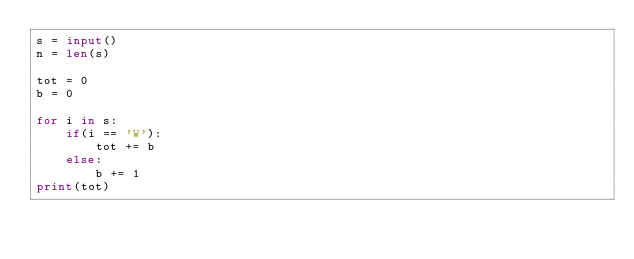Convert code to text. <code><loc_0><loc_0><loc_500><loc_500><_Python_>s = input()
n = len(s)

tot = 0
b = 0

for i in s:
    if(i == 'W'):
        tot += b
    else:
        b += 1
print(tot)</code> 